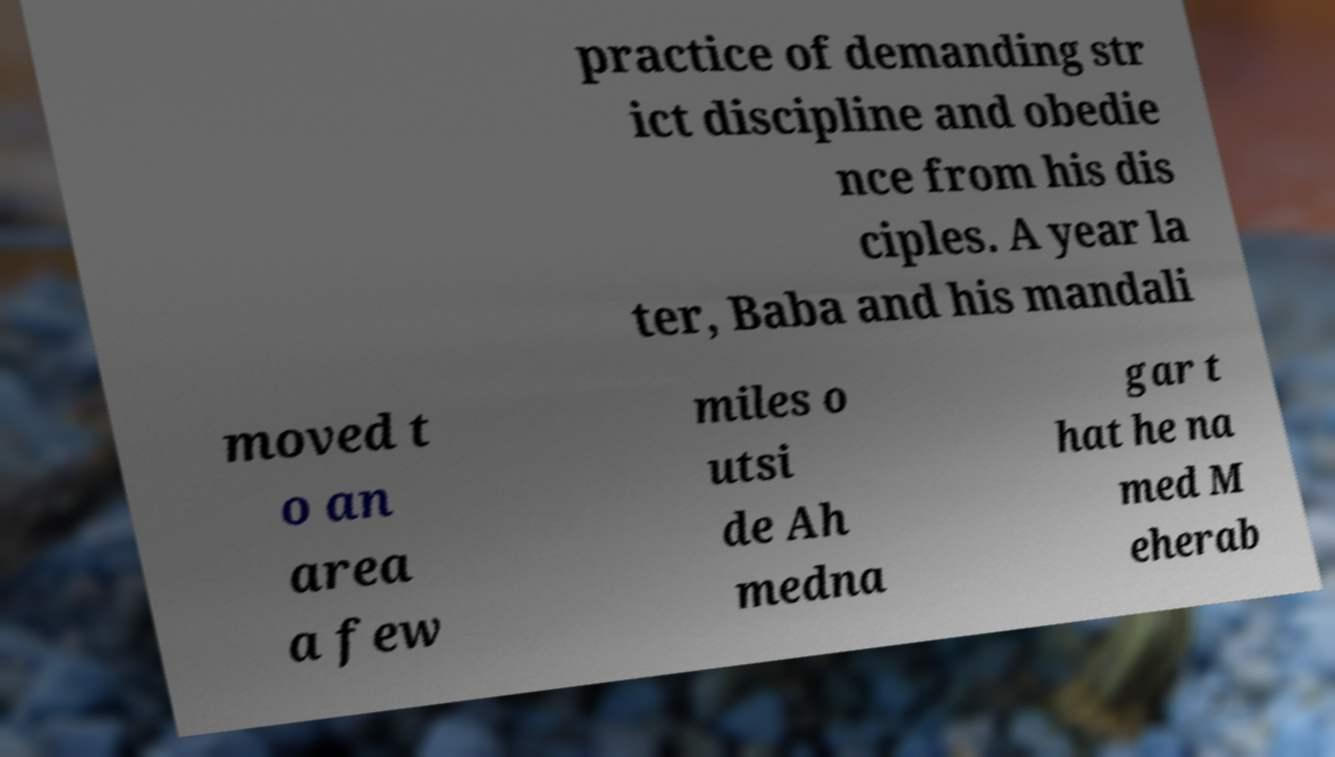There's text embedded in this image that I need extracted. Can you transcribe it verbatim? practice of demanding str ict discipline and obedie nce from his dis ciples. A year la ter, Baba and his mandali moved t o an area a few miles o utsi de Ah medna gar t hat he na med M eherab 